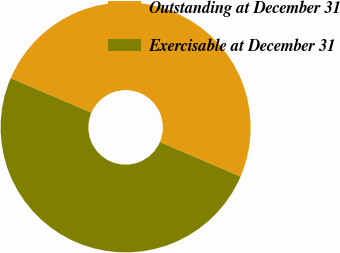Convert chart to OTSL. <chart><loc_0><loc_0><loc_500><loc_500><pie_chart><fcel>Outstanding at December 31<fcel>Exercisable at December 31<nl><fcel>50.01%<fcel>49.99%<nl></chart> 